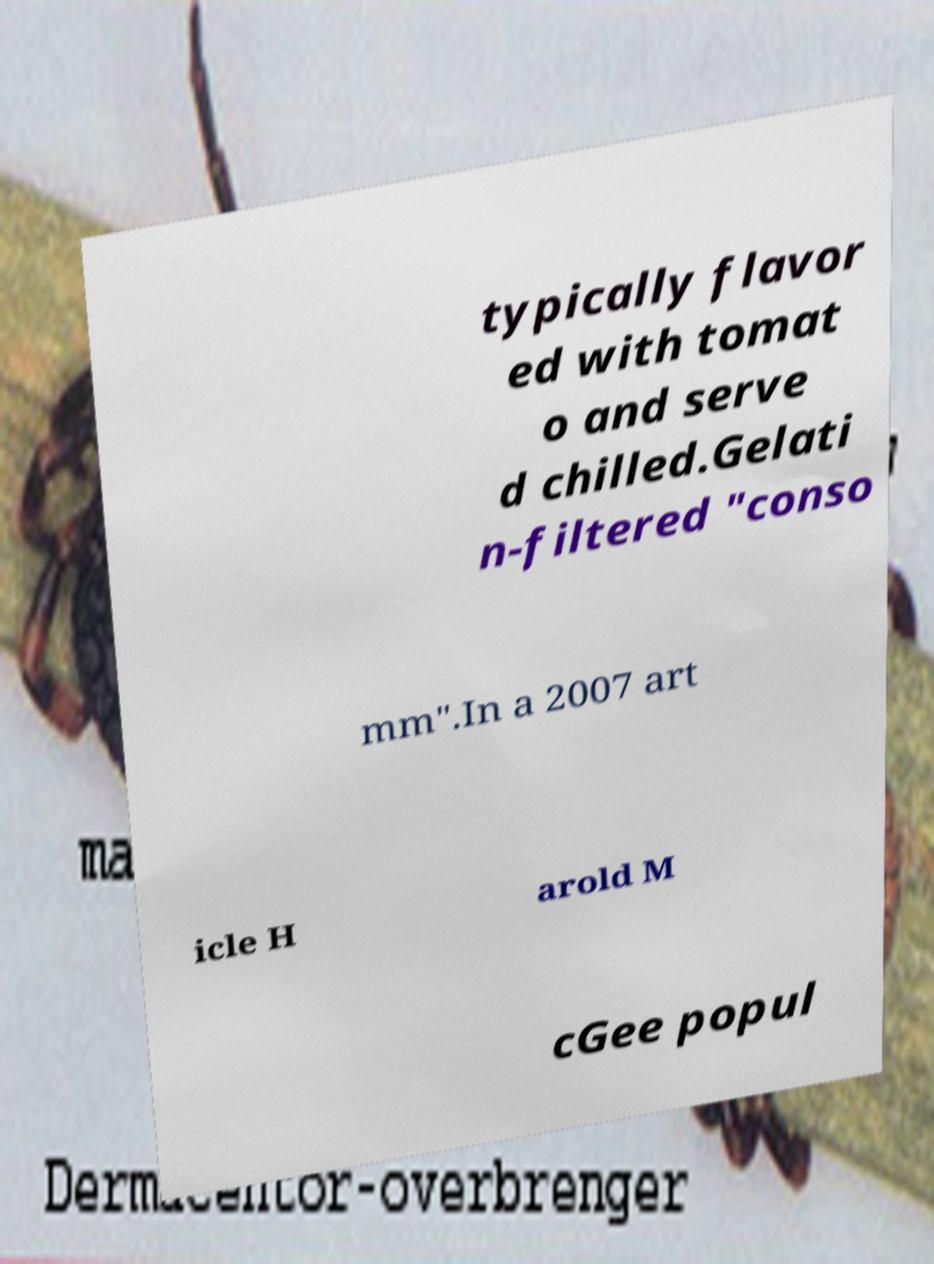Can you read and provide the text displayed in the image?This photo seems to have some interesting text. Can you extract and type it out for me? typically flavor ed with tomat o and serve d chilled.Gelati n-filtered "conso mm".In a 2007 art icle H arold M cGee popul 